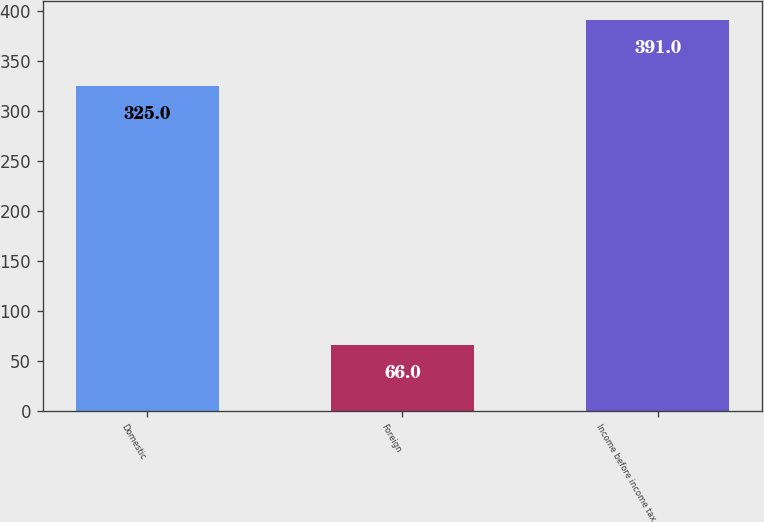Convert chart to OTSL. <chart><loc_0><loc_0><loc_500><loc_500><bar_chart><fcel>Domestic<fcel>Foreign<fcel>Income before income tax<nl><fcel>325<fcel>66<fcel>391<nl></chart> 